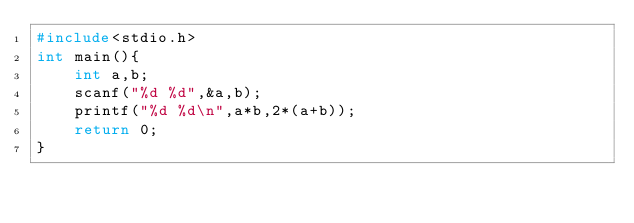<code> <loc_0><loc_0><loc_500><loc_500><_C_>#include<stdio.h>
int main(){
    int a,b;
    scanf("%d %d",&a,b);
    printf("%d %d\n",a*b,2*(a+b));
    return 0;
}
</code> 